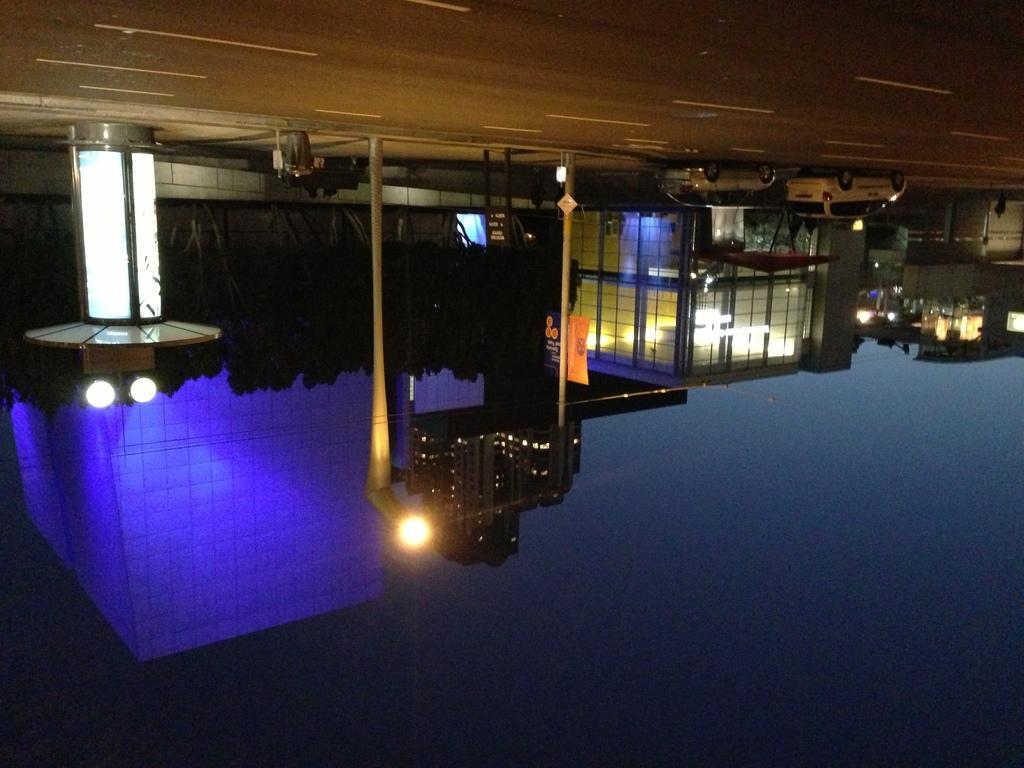What is the main feature of the image? There is a road in the image. What can be seen on the road? There are vehicles parked on the road. What type of natural elements are present in the image? There are trees in the image. What type of man-made structures can be seen in the image? There are buildings in the image. What type of stone can be seen on the roof of the buildings in the image? There is no mention of stone on the roof of the buildings in the image. Can you see any owls perched on the trees in the image? There are no owls visible in the image. 